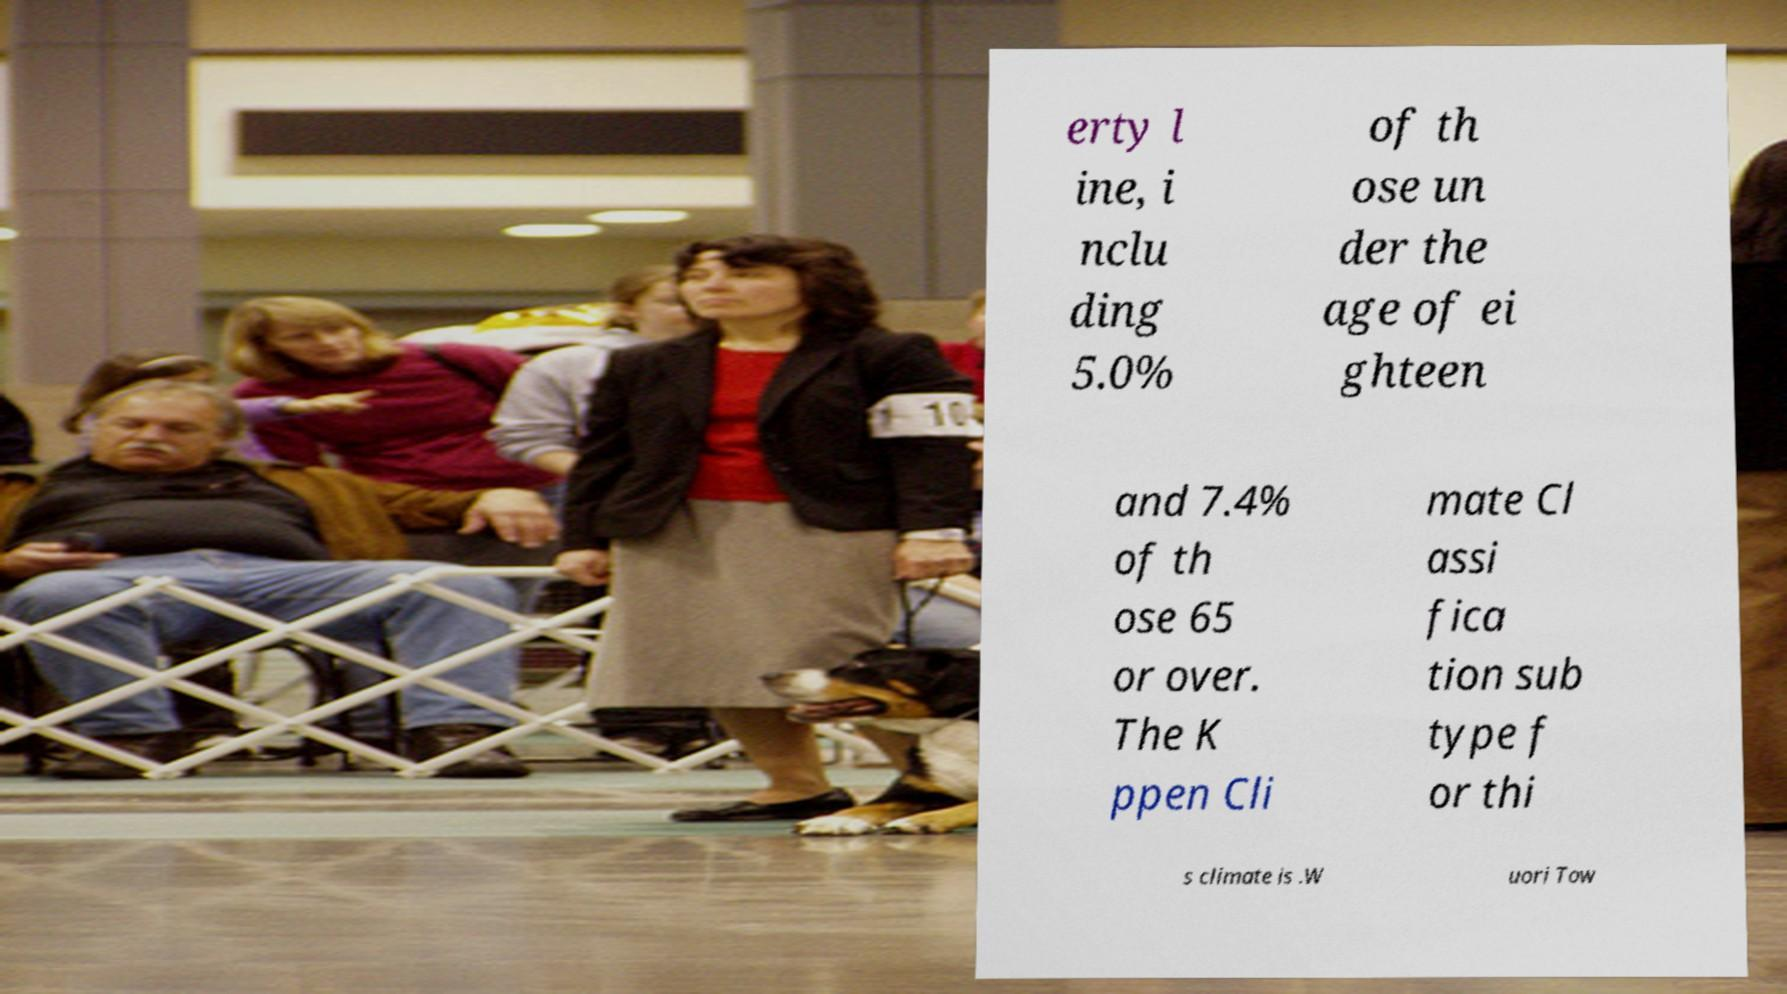What messages or text are displayed in this image? I need them in a readable, typed format. erty l ine, i nclu ding 5.0% of th ose un der the age of ei ghteen and 7.4% of th ose 65 or over. The K ppen Cli mate Cl assi fica tion sub type f or thi s climate is .W uori Tow 